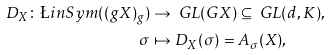<formula> <loc_0><loc_0><loc_500><loc_500>D _ { X } \colon \L i n S y m ( ( g X ) _ { g } ) & \to \ G L ( G X ) \subseteq \ G L ( d , K ) , \\ \sigma & \mapsto D _ { X } ( \sigma ) = A _ { \sigma } ( X ) ,</formula> 